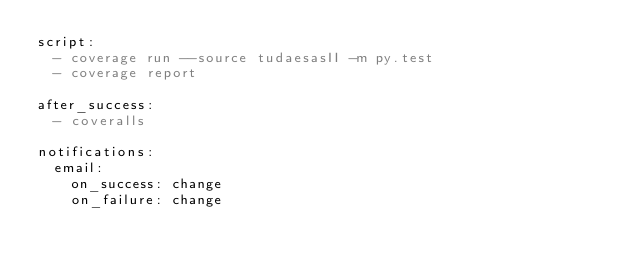<code> <loc_0><loc_0><loc_500><loc_500><_YAML_>script:
  - coverage run --source tudaesasII -m py.test
  - coverage report

after_success:
  - coveralls

notifications:
  email:
    on_success: change
    on_failure: change

</code> 